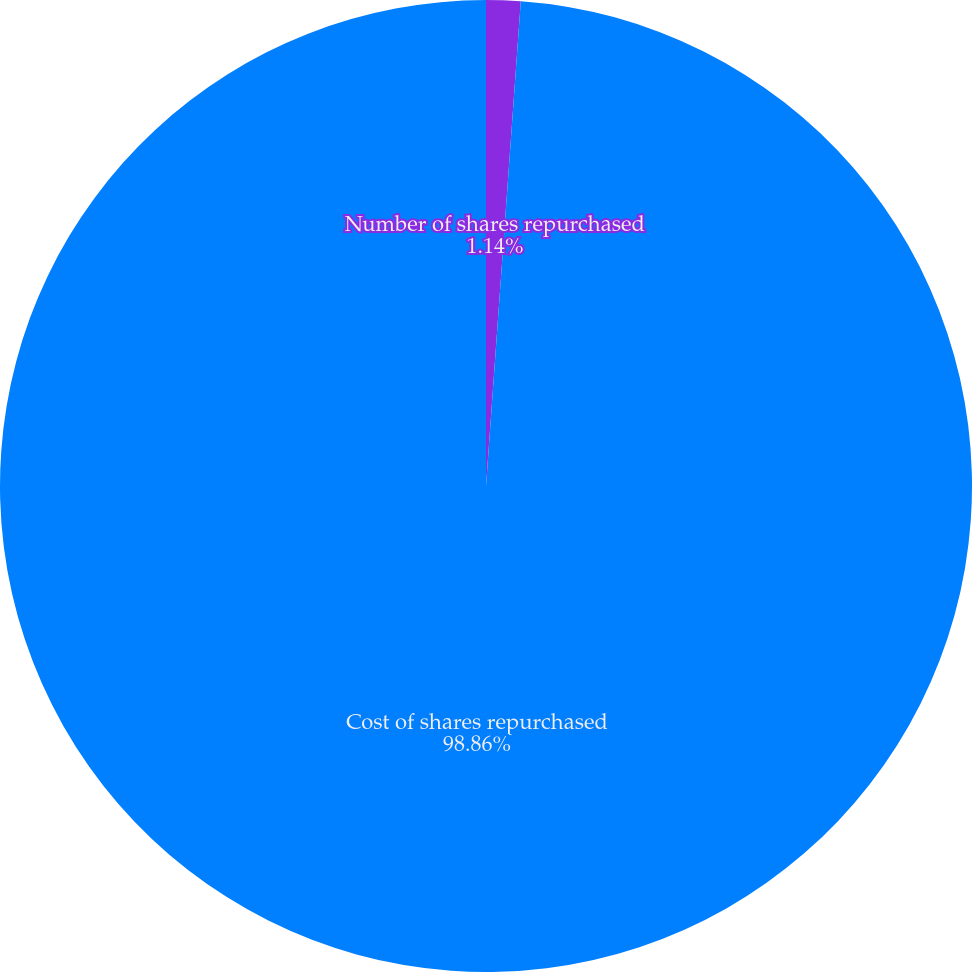<chart> <loc_0><loc_0><loc_500><loc_500><pie_chart><fcel>Number of shares repurchased<fcel>Cost of shares repurchased<nl><fcel>1.14%<fcel>98.86%<nl></chart> 